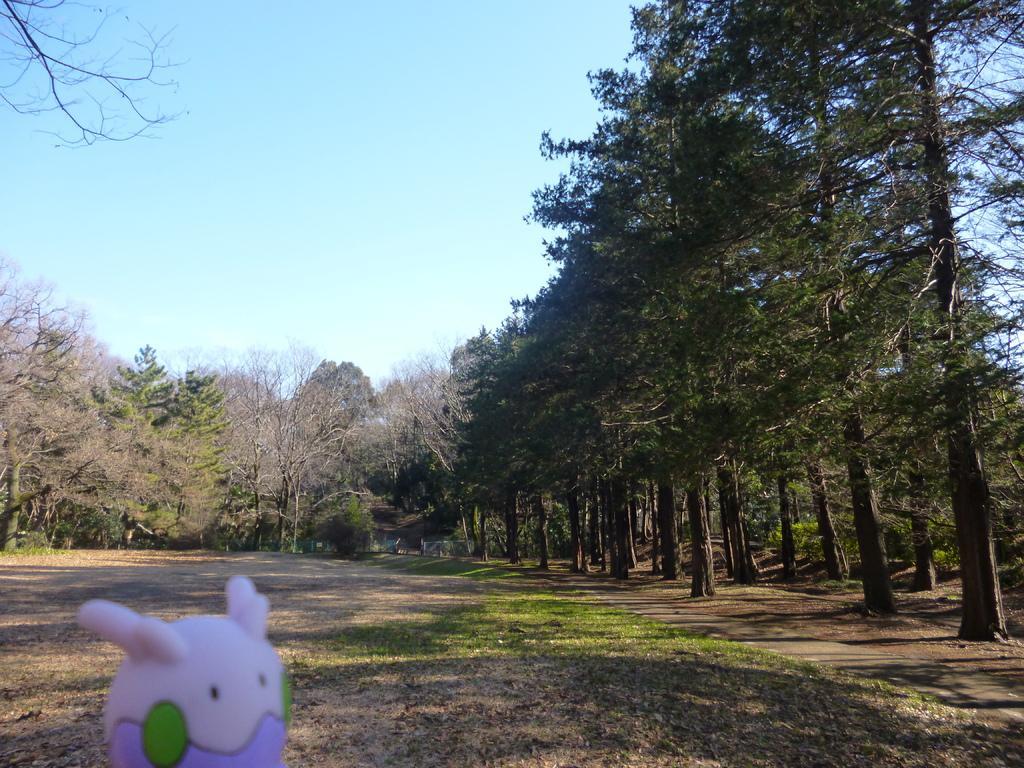How would you summarize this image in a sentence or two? In front of the image there is a toy. At the bottom of the image there is grass on the surface. In the background of the image there are trees. At the top of the image there is sky. 